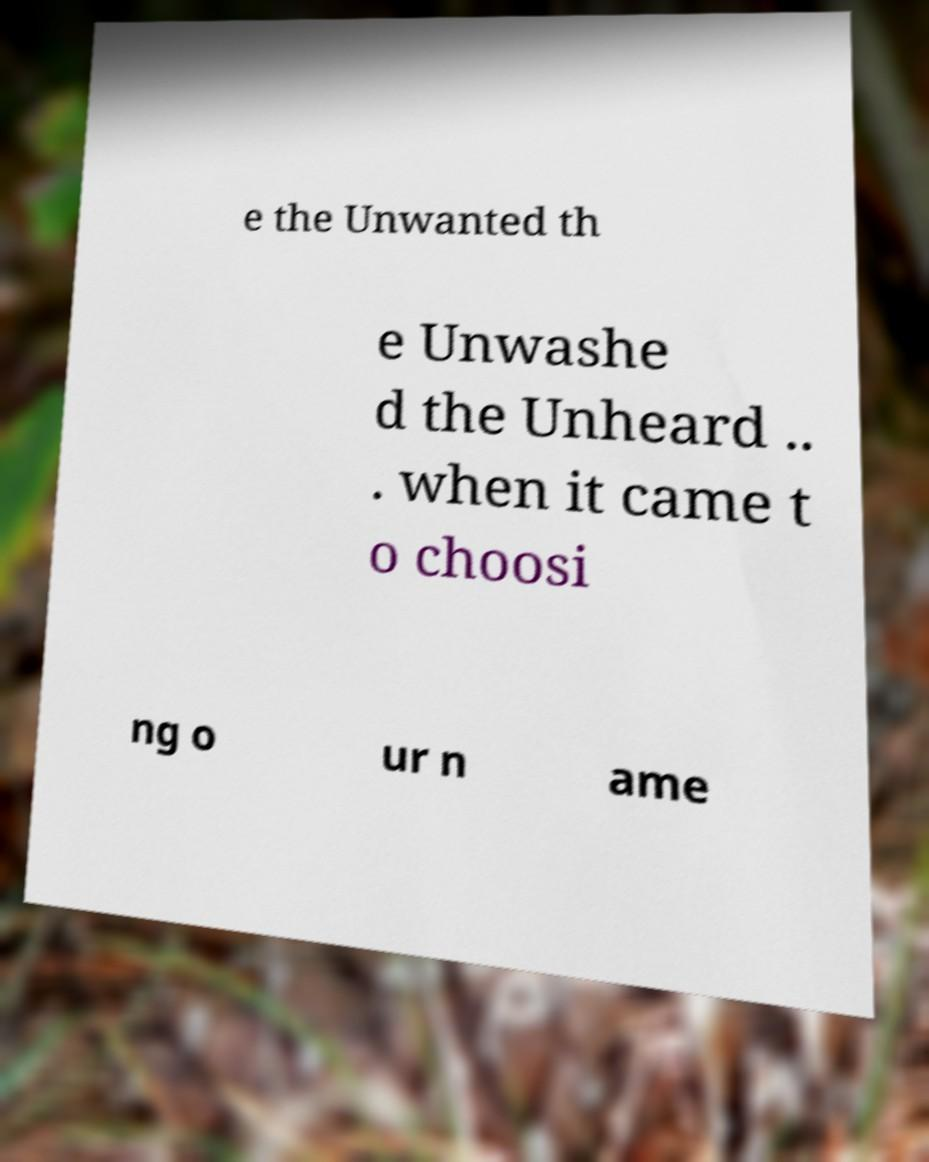Could you extract and type out the text from this image? e the Unwanted th e Unwashe d the Unheard .. . when it came t o choosi ng o ur n ame 